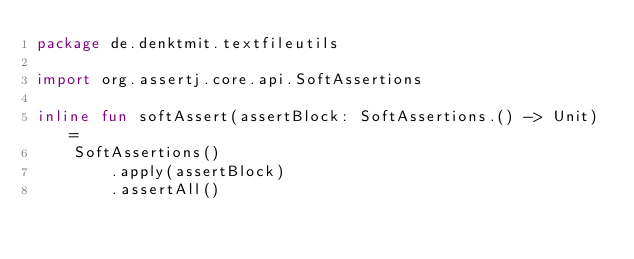Convert code to text. <code><loc_0><loc_0><loc_500><loc_500><_Kotlin_>package de.denktmit.textfileutils

import org.assertj.core.api.SoftAssertions

inline fun softAssert(assertBlock: SoftAssertions.() -> Unit) =
    SoftAssertions()
        .apply(assertBlock)
        .assertAll()</code> 